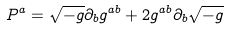Convert formula to latex. <formula><loc_0><loc_0><loc_500><loc_500>P ^ { a } = \sqrt { - g } \partial _ { b } g ^ { a b } + 2 g ^ { a b } \partial _ { b } \sqrt { - g }</formula> 